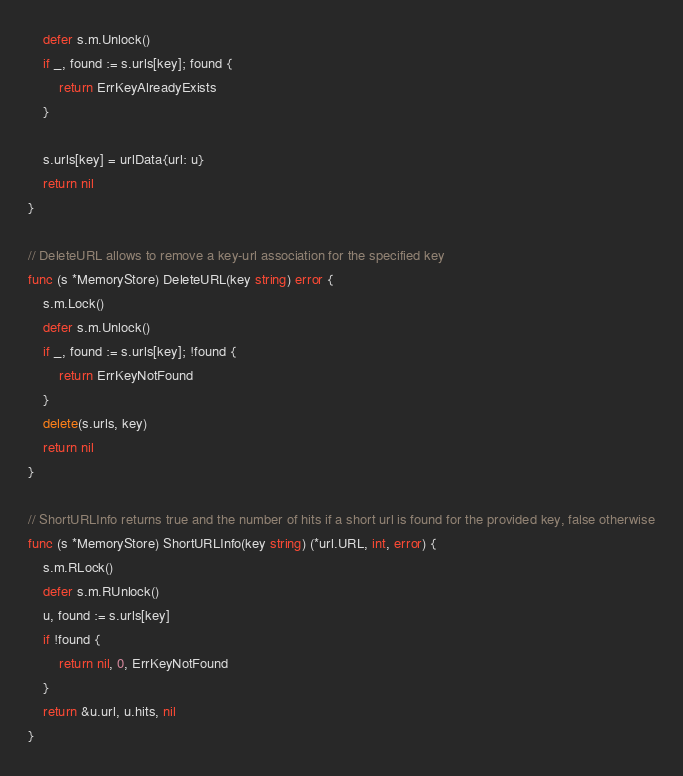<code> <loc_0><loc_0><loc_500><loc_500><_Go_>	defer s.m.Unlock()
	if _, found := s.urls[key]; found {
		return ErrKeyAlreadyExists
	}

	s.urls[key] = urlData{url: u}
	return nil
}

// DeleteURL allows to remove a key-url association for the specified key
func (s *MemoryStore) DeleteURL(key string) error {
	s.m.Lock()
	defer s.m.Unlock()
	if _, found := s.urls[key]; !found {
		return ErrKeyNotFound
	}
	delete(s.urls, key)
	return nil
}

// ShortURLInfo returns true and the number of hits if a short url is found for the provided key, false otherwise
func (s *MemoryStore) ShortURLInfo(key string) (*url.URL, int, error) {
	s.m.RLock()
	defer s.m.RUnlock()
	u, found := s.urls[key]
	if !found {
		return nil, 0, ErrKeyNotFound
	}
	return &u.url, u.hits, nil
}
</code> 